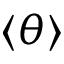Convert formula to latex. <formula><loc_0><loc_0><loc_500><loc_500>\langle \theta \rangle</formula> 